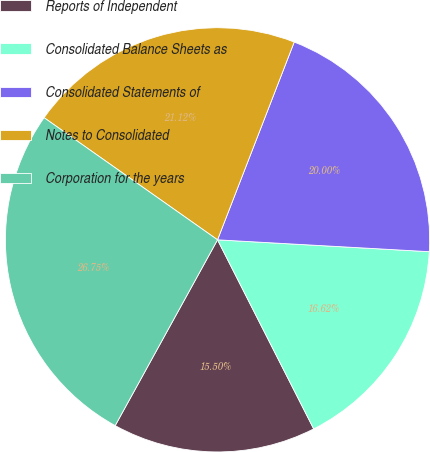<chart> <loc_0><loc_0><loc_500><loc_500><pie_chart><fcel>Reports of Independent<fcel>Consolidated Balance Sheets as<fcel>Consolidated Statements of<fcel>Notes to Consolidated<fcel>Corporation for the years<nl><fcel>15.5%<fcel>16.62%<fcel>20.0%<fcel>21.12%<fcel>26.75%<nl></chart> 